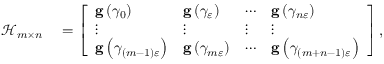<formula> <loc_0><loc_0><loc_500><loc_500>\begin{array} { r l } { \mathcal { H } _ { m \times n } } & = \left [ \begin{array} { l l l l } { g \left ( \gamma _ { 0 } \right ) } & { g \left ( \gamma _ { \varepsilon } \right ) } & { \cdots } & { g \left ( \gamma _ { n \varepsilon } \right ) } \\ { \vdots } & { \vdots } & { \vdots } & { \vdots } \\ { g \left ( \gamma _ { \left ( m - 1 \right ) \varepsilon } \right ) } & { g \left ( \gamma _ { m \varepsilon } \right ) } & { \cdots } & { g \left ( \gamma _ { \left ( m + n - 1 \right ) \varepsilon } \right ) } \end{array} \right ] , } \end{array}</formula> 